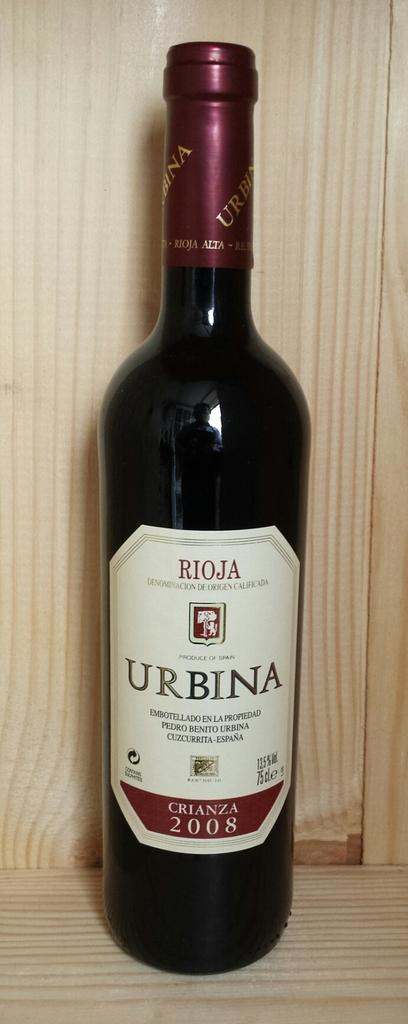Provide a one-sentence caption for the provided image. The bottle of Rioja was made in 2008. 